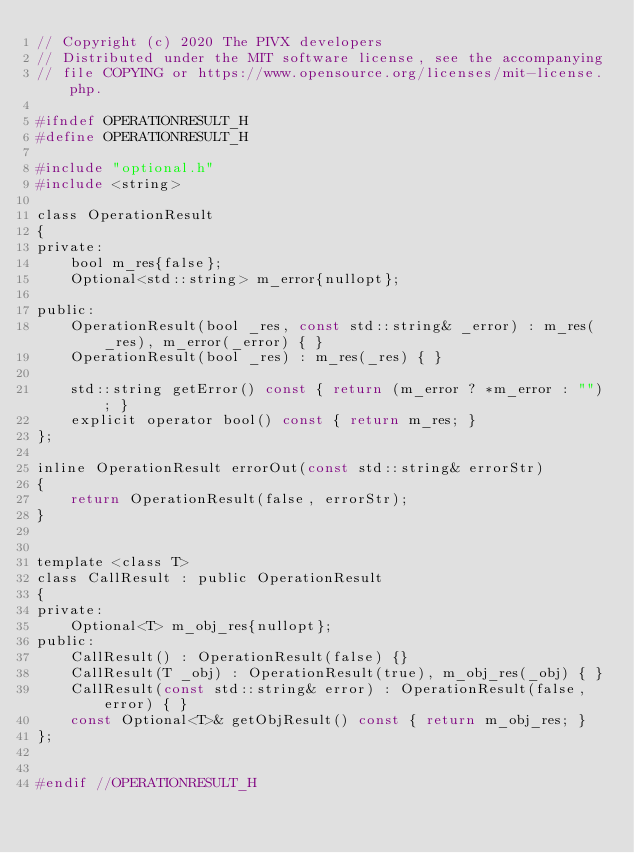Convert code to text. <code><loc_0><loc_0><loc_500><loc_500><_C_>// Copyright (c) 2020 The PIVX developers
// Distributed under the MIT software license, see the accompanying
// file COPYING or https://www.opensource.org/licenses/mit-license.php.

#ifndef OPERATIONRESULT_H
#define OPERATIONRESULT_H

#include "optional.h"
#include <string>

class OperationResult
{
private:
    bool m_res{false};
    Optional<std::string> m_error{nullopt};

public:
    OperationResult(bool _res, const std::string& _error) : m_res(_res), m_error(_error) { }
    OperationResult(bool _res) : m_res(_res) { }

    std::string getError() const { return (m_error ? *m_error : ""); }
    explicit operator bool() const { return m_res; }
};

inline OperationResult errorOut(const std::string& errorStr)
{
    return OperationResult(false, errorStr);
}


template <class T>
class CallResult : public OperationResult
{
private:
    Optional<T> m_obj_res{nullopt};
public:
    CallResult() : OperationResult(false) {}
    CallResult(T _obj) : OperationResult(true), m_obj_res(_obj) { }
    CallResult(const std::string& error) : OperationResult(false, error) { }
    const Optional<T>& getObjResult() const { return m_obj_res; }
};


#endif //OPERATIONRESULT_H
</code> 